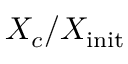Convert formula to latex. <formula><loc_0><loc_0><loc_500><loc_500>X _ { c } / X _ { i n i t }</formula> 